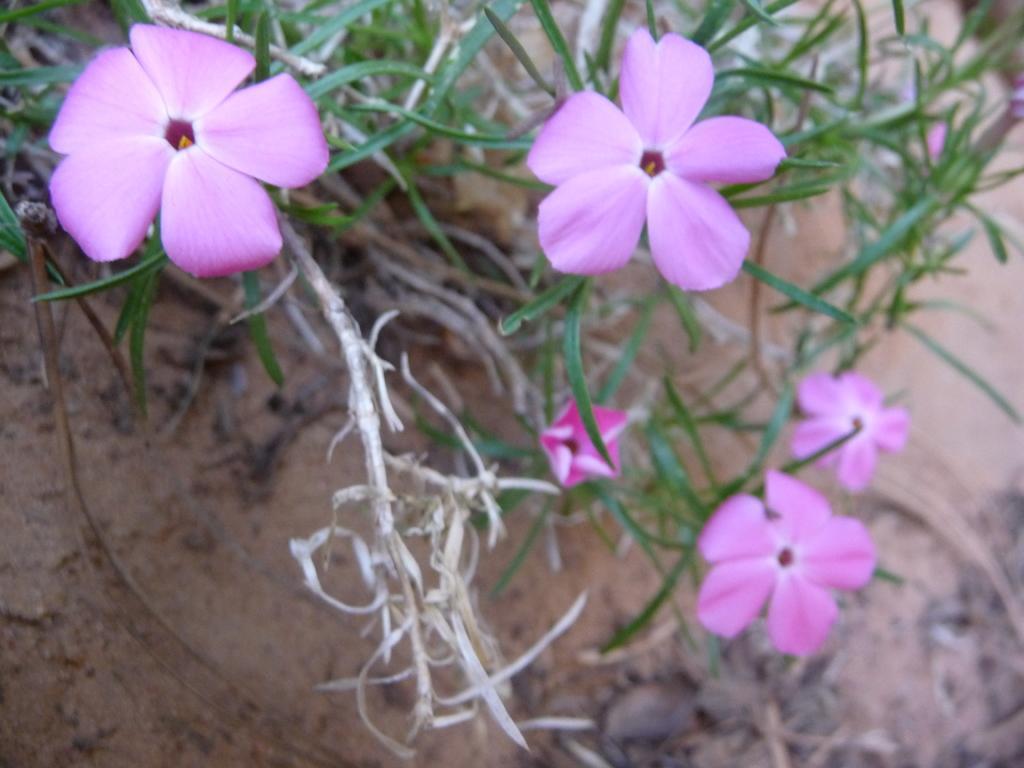Can you describe this image briefly? It is a zoom in picture of pink color flowers to the plant. 